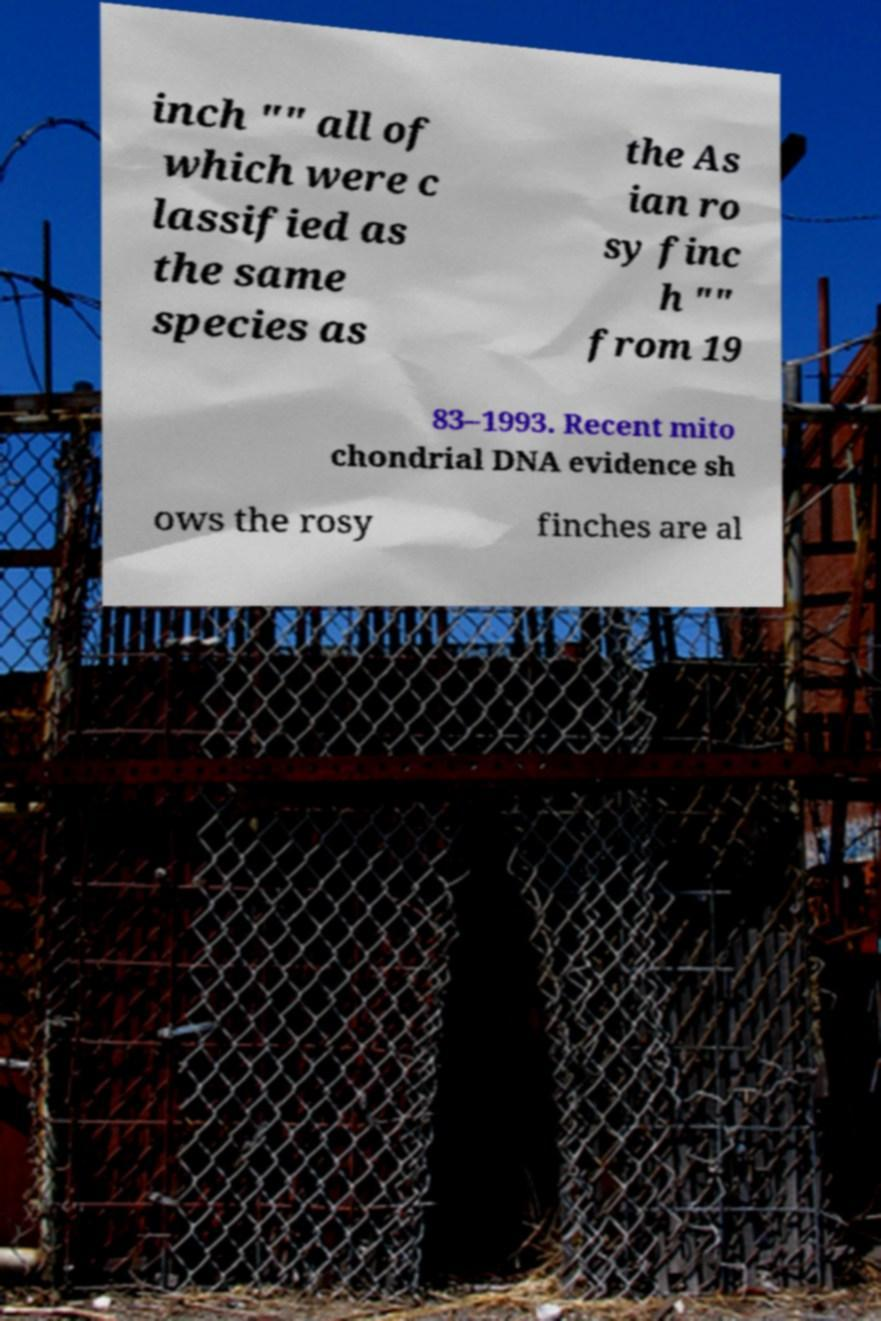There's text embedded in this image that I need extracted. Can you transcribe it verbatim? inch "" all of which were c lassified as the same species as the As ian ro sy finc h "" from 19 83–1993. Recent mito chondrial DNA evidence sh ows the rosy finches are al 